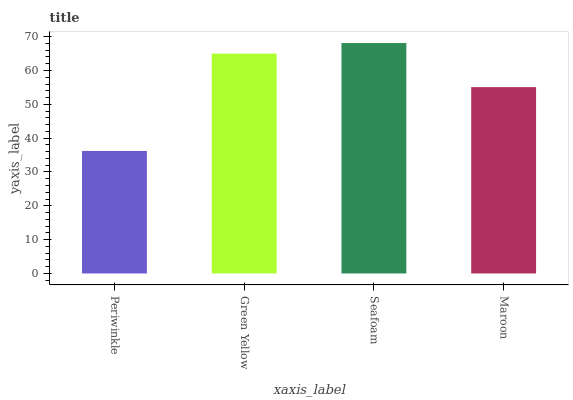Is Periwinkle the minimum?
Answer yes or no. Yes. Is Seafoam the maximum?
Answer yes or no. Yes. Is Green Yellow the minimum?
Answer yes or no. No. Is Green Yellow the maximum?
Answer yes or no. No. Is Green Yellow greater than Periwinkle?
Answer yes or no. Yes. Is Periwinkle less than Green Yellow?
Answer yes or no. Yes. Is Periwinkle greater than Green Yellow?
Answer yes or no. No. Is Green Yellow less than Periwinkle?
Answer yes or no. No. Is Green Yellow the high median?
Answer yes or no. Yes. Is Maroon the low median?
Answer yes or no. Yes. Is Maroon the high median?
Answer yes or no. No. Is Seafoam the low median?
Answer yes or no. No. 